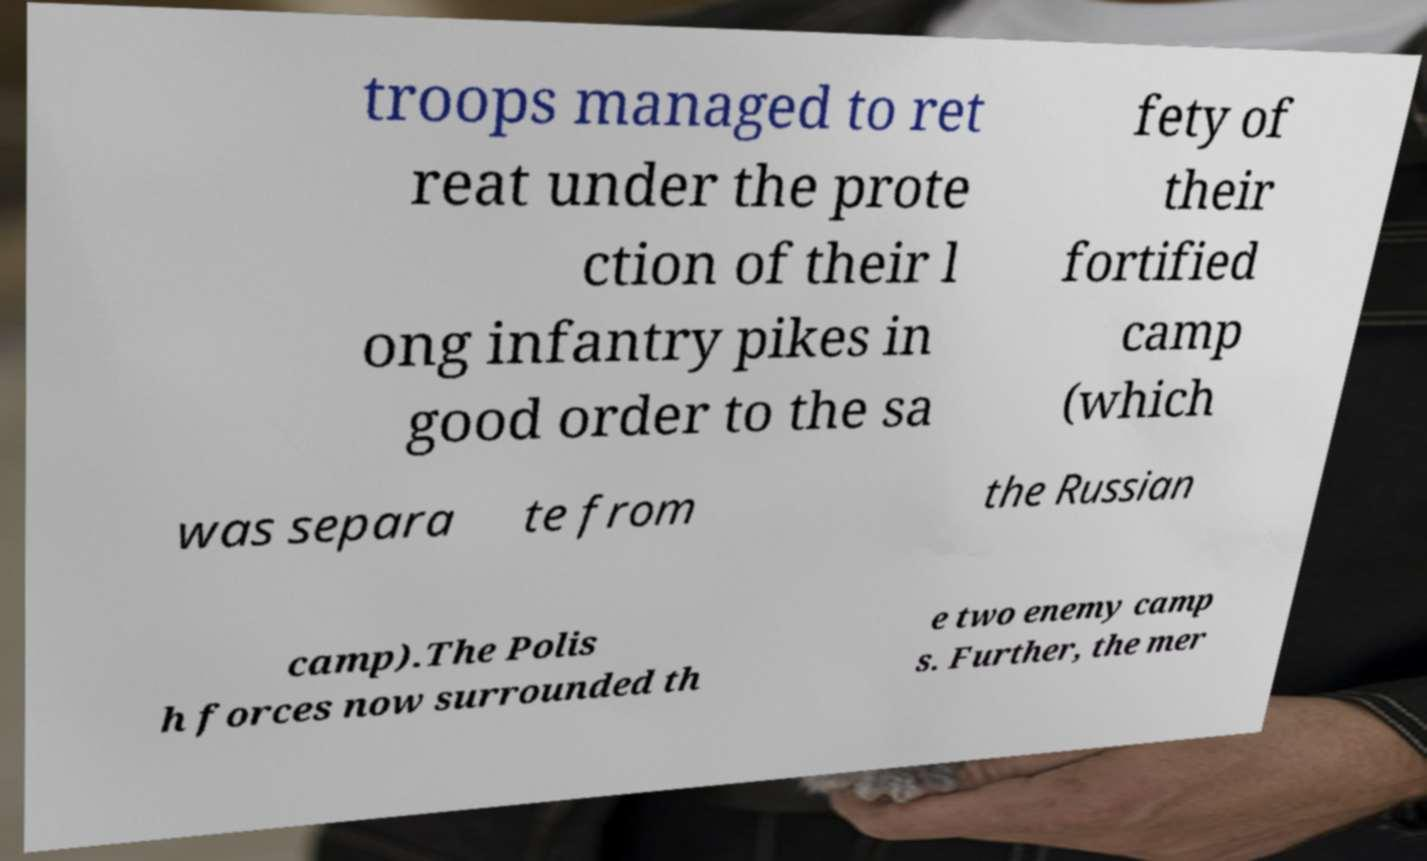I need the written content from this picture converted into text. Can you do that? troops managed to ret reat under the prote ction of their l ong infantry pikes in good order to the sa fety of their fortified camp (which was separa te from the Russian camp).The Polis h forces now surrounded th e two enemy camp s. Further, the mer 